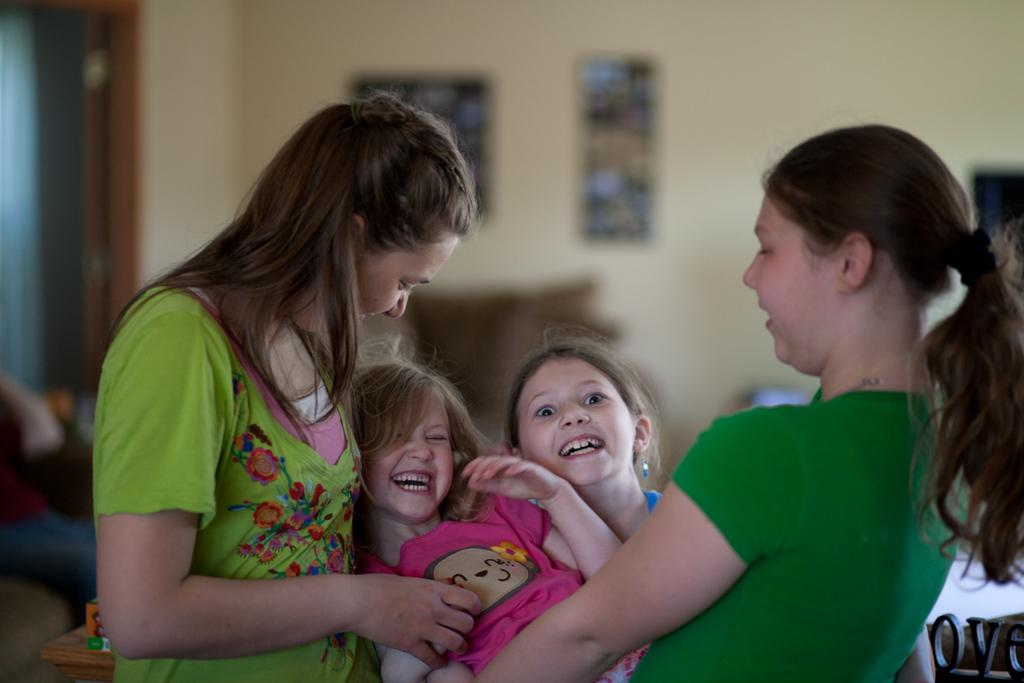Who or what can be seen in the image? There are people in the image. What is present on the wall in the image? There are frames on the wall in the image. What type of lettuce is being served at the event in the image? There is no lettuce or event present in the image; it only features people and frames on the wall. 